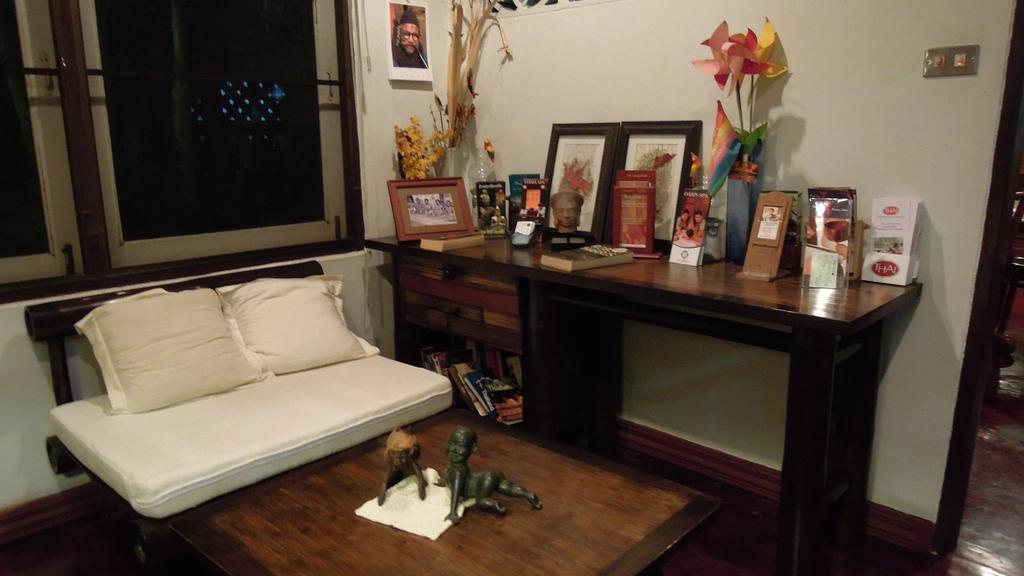Where is the image taken? The image is inside a room. What furniture can be seen in the room? There is a table and a bed in the room. What is on the bed? There is a pillow and toys on the bed. What is on the table? There are frames on the table. What is visible on the wall? There is a window in the background. What type of harmony is being played in the room? There is no indication of any music or harmony being played in the room. Can you confirm the existence of the sky in the image? The sky is not visible in the image, as it is taken inside a room. 